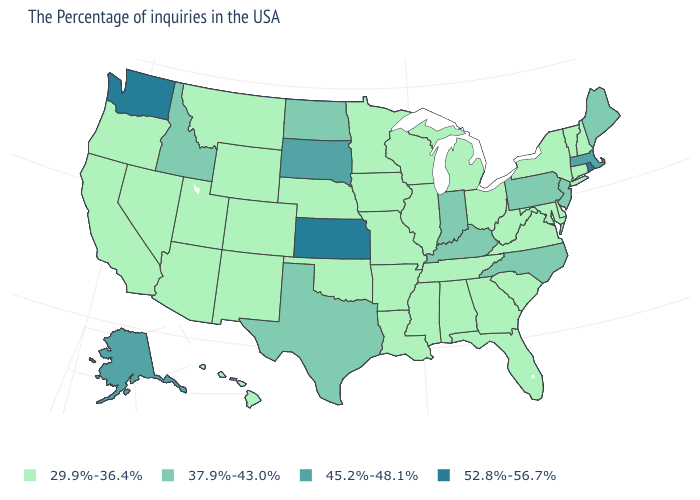Does the map have missing data?
Concise answer only. No. Which states have the lowest value in the MidWest?
Short answer required. Ohio, Michigan, Wisconsin, Illinois, Missouri, Minnesota, Iowa, Nebraska. What is the lowest value in the West?
Write a very short answer. 29.9%-36.4%. What is the value of Alaska?
Short answer required. 45.2%-48.1%. Name the states that have a value in the range 37.9%-43.0%?
Be succinct. Maine, New Jersey, Pennsylvania, North Carolina, Kentucky, Indiana, Texas, North Dakota, Idaho. Does Illinois have the lowest value in the USA?
Keep it brief. Yes. How many symbols are there in the legend?
Be succinct. 4. Does Kansas have the highest value in the USA?
Keep it brief. Yes. What is the value of Minnesota?
Quick response, please. 29.9%-36.4%. Is the legend a continuous bar?
Be succinct. No. Which states have the lowest value in the USA?
Short answer required. New Hampshire, Vermont, Connecticut, New York, Delaware, Maryland, Virginia, South Carolina, West Virginia, Ohio, Florida, Georgia, Michigan, Alabama, Tennessee, Wisconsin, Illinois, Mississippi, Louisiana, Missouri, Arkansas, Minnesota, Iowa, Nebraska, Oklahoma, Wyoming, Colorado, New Mexico, Utah, Montana, Arizona, Nevada, California, Oregon, Hawaii. Does the map have missing data?
Quick response, please. No. What is the lowest value in the South?
Quick response, please. 29.9%-36.4%. Does Kansas have the highest value in the MidWest?
Be succinct. Yes. What is the value of Pennsylvania?
Concise answer only. 37.9%-43.0%. 